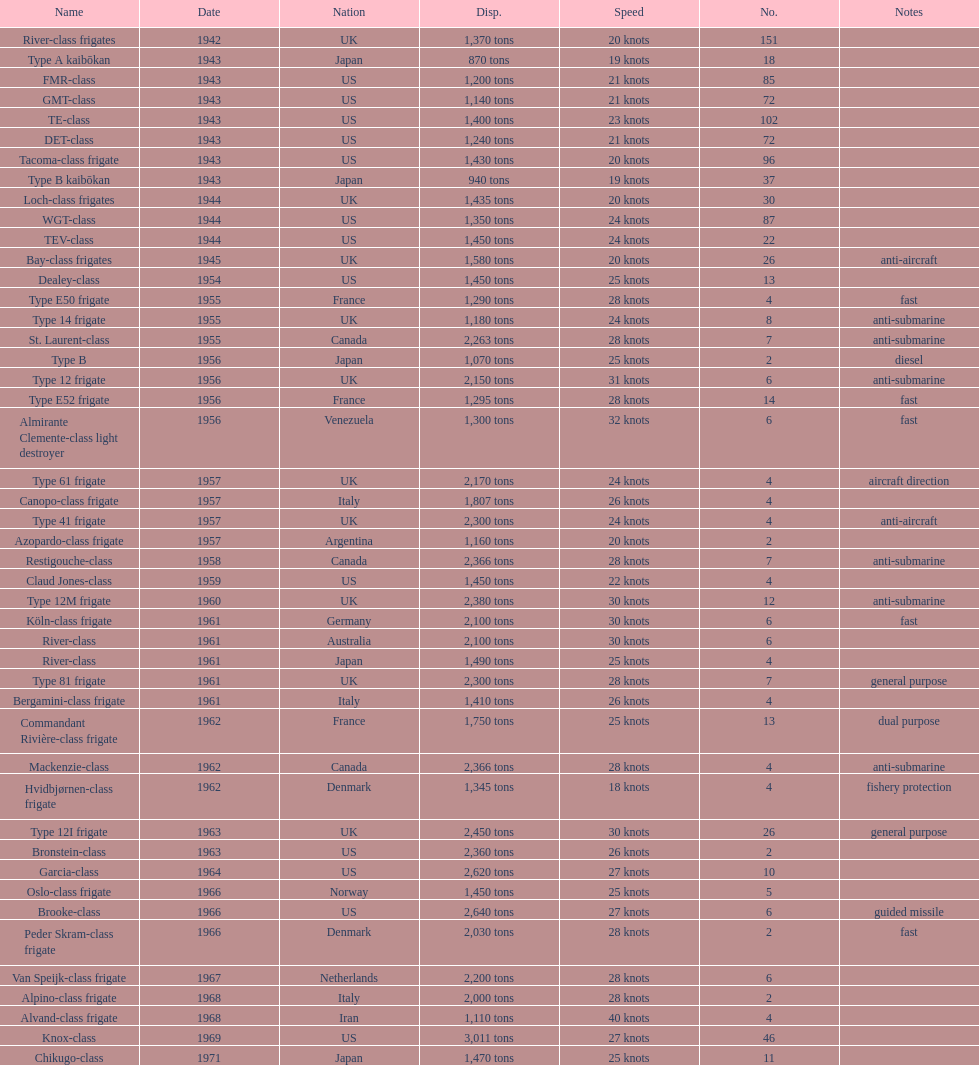What is the difference in speed for the gmt-class and the te-class? 2 knots. 